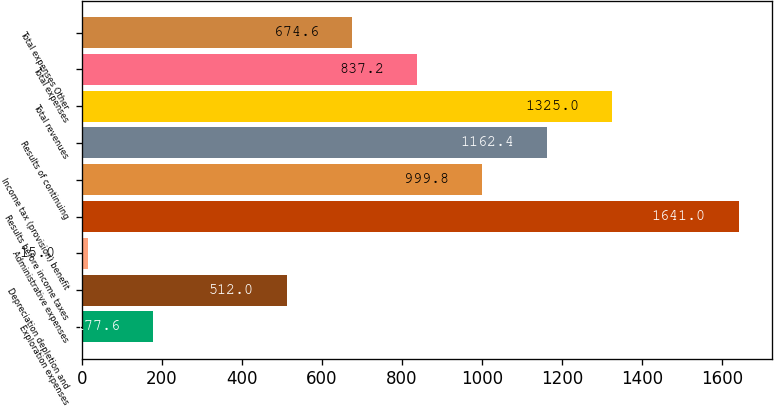Convert chart. <chart><loc_0><loc_0><loc_500><loc_500><bar_chart><fcel>Exploration expenses<fcel>Depreciation depletion and<fcel>Administrative expenses<fcel>Results before income taxes<fcel>Income tax (provision) benefit<fcel>Results of continuing<fcel>Total revenues<fcel>Total expenses<fcel>Total expenses Other<nl><fcel>177.6<fcel>512<fcel>15<fcel>1641<fcel>999.8<fcel>1162.4<fcel>1325<fcel>837.2<fcel>674.6<nl></chart> 